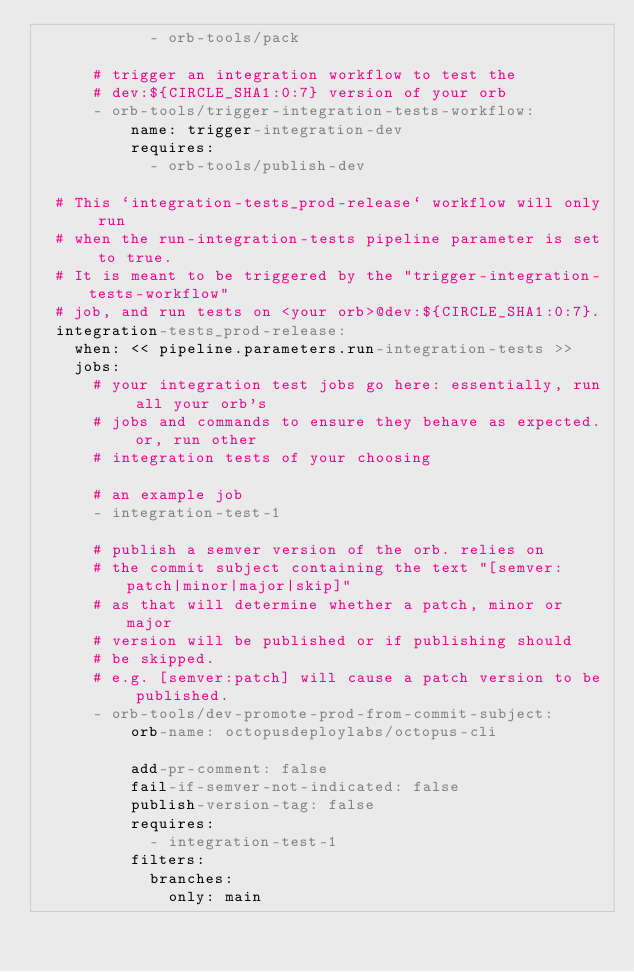Convert code to text. <code><loc_0><loc_0><loc_500><loc_500><_YAML_>            - orb-tools/pack

      # trigger an integration workflow to test the
      # dev:${CIRCLE_SHA1:0:7} version of your orb
      - orb-tools/trigger-integration-tests-workflow:
          name: trigger-integration-dev
          requires:
            - orb-tools/publish-dev

  # This `integration-tests_prod-release` workflow will only run
  # when the run-integration-tests pipeline parameter is set to true.
  # It is meant to be triggered by the "trigger-integration-tests-workflow"
  # job, and run tests on <your orb>@dev:${CIRCLE_SHA1:0:7}.
  integration-tests_prod-release:
    when: << pipeline.parameters.run-integration-tests >>
    jobs:
      # your integration test jobs go here: essentially, run all your orb's
      # jobs and commands to ensure they behave as expected. or, run other
      # integration tests of your choosing

      # an example job
      - integration-test-1

      # publish a semver version of the orb. relies on
      # the commit subject containing the text "[semver:patch|minor|major|skip]"
      # as that will determine whether a patch, minor or major
      # version will be published or if publishing should
      # be skipped.
      # e.g. [semver:patch] will cause a patch version to be published.
      - orb-tools/dev-promote-prod-from-commit-subject:
          orb-name: octopusdeploylabs/octopus-cli

          add-pr-comment: false
          fail-if-semver-not-indicated: false
          publish-version-tag: false
          requires:
            - integration-test-1
          filters:
            branches:
              only: main
</code> 